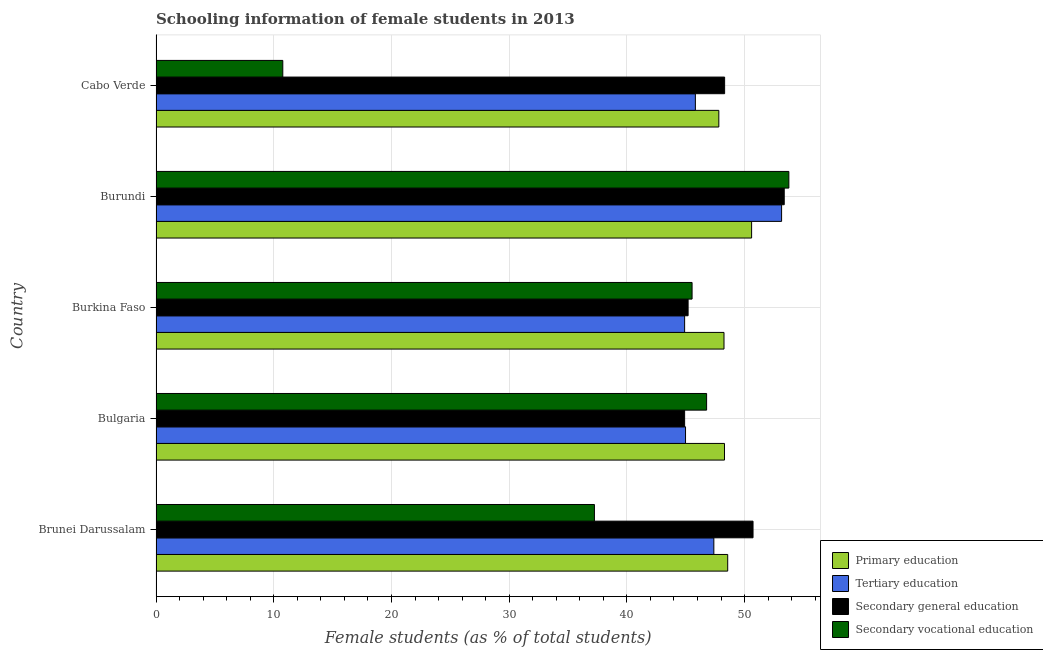How many groups of bars are there?
Your answer should be very brief. 5. Are the number of bars per tick equal to the number of legend labels?
Your answer should be very brief. Yes. Are the number of bars on each tick of the Y-axis equal?
Provide a short and direct response. Yes. How many bars are there on the 5th tick from the top?
Keep it short and to the point. 4. What is the label of the 3rd group of bars from the top?
Your answer should be very brief. Burkina Faso. What is the percentage of female students in tertiary education in Cabo Verde?
Give a very brief answer. 45.82. Across all countries, what is the maximum percentage of female students in tertiary education?
Your response must be concise. 53.14. Across all countries, what is the minimum percentage of female students in primary education?
Offer a very short reply. 47.81. In which country was the percentage of female students in secondary education maximum?
Provide a short and direct response. Burundi. What is the total percentage of female students in secondary education in the graph?
Offer a very short reply. 242.49. What is the difference between the percentage of female students in secondary education in Burundi and that in Cabo Verde?
Give a very brief answer. 5.07. What is the difference between the percentage of female students in secondary vocational education in Bulgaria and the percentage of female students in primary education in Cabo Verde?
Provide a short and direct response. -1.04. What is the average percentage of female students in secondary vocational education per country?
Offer a terse response. 38.82. What is the difference between the percentage of female students in tertiary education and percentage of female students in secondary education in Bulgaria?
Offer a very short reply. 0.08. In how many countries, is the percentage of female students in tertiary education greater than 48 %?
Offer a terse response. 1. What is the ratio of the percentage of female students in tertiary education in Bulgaria to that in Burundi?
Your answer should be compact. 0.85. Is the percentage of female students in secondary vocational education in Bulgaria less than that in Burkina Faso?
Ensure brevity in your answer.  No. What is the difference between the highest and the second highest percentage of female students in secondary vocational education?
Offer a terse response. 6.99. What is the difference between the highest and the lowest percentage of female students in tertiary education?
Provide a succinct answer. 8.24. Is the sum of the percentage of female students in secondary education in Brunei Darussalam and Bulgaria greater than the maximum percentage of female students in secondary vocational education across all countries?
Make the answer very short. Yes. Is it the case that in every country, the sum of the percentage of female students in tertiary education and percentage of female students in secondary education is greater than the sum of percentage of female students in primary education and percentage of female students in secondary vocational education?
Your answer should be very brief. No. What does the 4th bar from the top in Burkina Faso represents?
Provide a succinct answer. Primary education. What does the 1st bar from the bottom in Burundi represents?
Provide a short and direct response. Primary education. Are all the bars in the graph horizontal?
Offer a very short reply. Yes. How many countries are there in the graph?
Provide a short and direct response. 5. Are the values on the major ticks of X-axis written in scientific E-notation?
Provide a succinct answer. No. Does the graph contain any zero values?
Your response must be concise. No. Where does the legend appear in the graph?
Your response must be concise. Bottom right. How many legend labels are there?
Keep it short and to the point. 4. How are the legend labels stacked?
Offer a terse response. Vertical. What is the title of the graph?
Provide a succinct answer. Schooling information of female students in 2013. Does "Argument" appear as one of the legend labels in the graph?
Offer a very short reply. No. What is the label or title of the X-axis?
Offer a terse response. Female students (as % of total students). What is the label or title of the Y-axis?
Keep it short and to the point. Country. What is the Female students (as % of total students) of Primary education in Brunei Darussalam?
Make the answer very short. 48.56. What is the Female students (as % of total students) of Tertiary education in Brunei Darussalam?
Provide a succinct answer. 47.39. What is the Female students (as % of total students) of Secondary general education in Brunei Darussalam?
Give a very brief answer. 50.72. What is the Female students (as % of total students) in Secondary vocational education in Brunei Darussalam?
Your answer should be very brief. 37.24. What is the Female students (as % of total students) in Primary education in Bulgaria?
Provide a succinct answer. 48.29. What is the Female students (as % of total students) of Tertiary education in Bulgaria?
Provide a succinct answer. 44.98. What is the Female students (as % of total students) in Secondary general education in Bulgaria?
Provide a succinct answer. 44.91. What is the Female students (as % of total students) in Secondary vocational education in Bulgaria?
Your answer should be very brief. 46.77. What is the Female students (as % of total students) of Primary education in Burkina Faso?
Offer a terse response. 48.25. What is the Female students (as % of total students) of Tertiary education in Burkina Faso?
Your answer should be very brief. 44.91. What is the Female students (as % of total students) of Secondary general education in Burkina Faso?
Keep it short and to the point. 45.2. What is the Female students (as % of total students) of Secondary vocational education in Burkina Faso?
Offer a terse response. 45.54. What is the Female students (as % of total students) of Primary education in Burundi?
Offer a very short reply. 50.6. What is the Female students (as % of total students) of Tertiary education in Burundi?
Your answer should be very brief. 53.14. What is the Female students (as % of total students) in Secondary general education in Burundi?
Provide a succinct answer. 53.37. What is the Female students (as % of total students) of Secondary vocational education in Burundi?
Offer a very short reply. 53.76. What is the Female students (as % of total students) in Primary education in Cabo Verde?
Provide a succinct answer. 47.81. What is the Female students (as % of total students) in Tertiary education in Cabo Verde?
Your answer should be very brief. 45.82. What is the Female students (as % of total students) in Secondary general education in Cabo Verde?
Your response must be concise. 48.3. What is the Female students (as % of total students) in Secondary vocational education in Cabo Verde?
Give a very brief answer. 10.77. Across all countries, what is the maximum Female students (as % of total students) in Primary education?
Offer a terse response. 50.6. Across all countries, what is the maximum Female students (as % of total students) of Tertiary education?
Your answer should be compact. 53.14. Across all countries, what is the maximum Female students (as % of total students) in Secondary general education?
Keep it short and to the point. 53.37. Across all countries, what is the maximum Female students (as % of total students) in Secondary vocational education?
Your answer should be very brief. 53.76. Across all countries, what is the minimum Female students (as % of total students) in Primary education?
Make the answer very short. 47.81. Across all countries, what is the minimum Female students (as % of total students) in Tertiary education?
Ensure brevity in your answer.  44.91. Across all countries, what is the minimum Female students (as % of total students) in Secondary general education?
Provide a succinct answer. 44.91. Across all countries, what is the minimum Female students (as % of total students) in Secondary vocational education?
Give a very brief answer. 10.77. What is the total Female students (as % of total students) of Primary education in the graph?
Provide a short and direct response. 243.52. What is the total Female students (as % of total students) in Tertiary education in the graph?
Give a very brief answer. 236.24. What is the total Female students (as % of total students) of Secondary general education in the graph?
Give a very brief answer. 242.49. What is the total Female students (as % of total students) in Secondary vocational education in the graph?
Provide a short and direct response. 194.08. What is the difference between the Female students (as % of total students) of Primary education in Brunei Darussalam and that in Bulgaria?
Give a very brief answer. 0.27. What is the difference between the Female students (as % of total students) of Tertiary education in Brunei Darussalam and that in Bulgaria?
Offer a terse response. 2.4. What is the difference between the Female students (as % of total students) of Secondary general education in Brunei Darussalam and that in Bulgaria?
Your answer should be very brief. 5.81. What is the difference between the Female students (as % of total students) in Secondary vocational education in Brunei Darussalam and that in Bulgaria?
Offer a terse response. -9.53. What is the difference between the Female students (as % of total students) of Primary education in Brunei Darussalam and that in Burkina Faso?
Keep it short and to the point. 0.31. What is the difference between the Female students (as % of total students) of Tertiary education in Brunei Darussalam and that in Burkina Faso?
Your answer should be compact. 2.48. What is the difference between the Female students (as % of total students) of Secondary general education in Brunei Darussalam and that in Burkina Faso?
Give a very brief answer. 5.52. What is the difference between the Female students (as % of total students) of Secondary vocational education in Brunei Darussalam and that in Burkina Faso?
Provide a succinct answer. -8.3. What is the difference between the Female students (as % of total students) of Primary education in Brunei Darussalam and that in Burundi?
Give a very brief answer. -2.03. What is the difference between the Female students (as % of total students) of Tertiary education in Brunei Darussalam and that in Burundi?
Your response must be concise. -5.76. What is the difference between the Female students (as % of total students) in Secondary general education in Brunei Darussalam and that in Burundi?
Provide a succinct answer. -2.65. What is the difference between the Female students (as % of total students) of Secondary vocational education in Brunei Darussalam and that in Burundi?
Your answer should be very brief. -16.52. What is the difference between the Female students (as % of total students) of Primary education in Brunei Darussalam and that in Cabo Verde?
Your answer should be compact. 0.75. What is the difference between the Female students (as % of total students) in Tertiary education in Brunei Darussalam and that in Cabo Verde?
Your response must be concise. 1.57. What is the difference between the Female students (as % of total students) in Secondary general education in Brunei Darussalam and that in Cabo Verde?
Keep it short and to the point. 2.41. What is the difference between the Female students (as % of total students) in Secondary vocational education in Brunei Darussalam and that in Cabo Verde?
Your answer should be very brief. 26.47. What is the difference between the Female students (as % of total students) in Primary education in Bulgaria and that in Burkina Faso?
Offer a terse response. 0.04. What is the difference between the Female students (as % of total students) of Tertiary education in Bulgaria and that in Burkina Faso?
Ensure brevity in your answer.  0.08. What is the difference between the Female students (as % of total students) of Secondary general education in Bulgaria and that in Burkina Faso?
Offer a very short reply. -0.3. What is the difference between the Female students (as % of total students) in Secondary vocational education in Bulgaria and that in Burkina Faso?
Give a very brief answer. 1.24. What is the difference between the Female students (as % of total students) in Primary education in Bulgaria and that in Burundi?
Offer a very short reply. -2.3. What is the difference between the Female students (as % of total students) of Tertiary education in Bulgaria and that in Burundi?
Your response must be concise. -8.16. What is the difference between the Female students (as % of total students) in Secondary general education in Bulgaria and that in Burundi?
Your answer should be very brief. -8.46. What is the difference between the Female students (as % of total students) of Secondary vocational education in Bulgaria and that in Burundi?
Your answer should be compact. -6.99. What is the difference between the Female students (as % of total students) in Primary education in Bulgaria and that in Cabo Verde?
Offer a very short reply. 0.48. What is the difference between the Female students (as % of total students) of Tertiary education in Bulgaria and that in Cabo Verde?
Give a very brief answer. -0.84. What is the difference between the Female students (as % of total students) of Secondary general education in Bulgaria and that in Cabo Verde?
Your response must be concise. -3.4. What is the difference between the Female students (as % of total students) in Secondary vocational education in Bulgaria and that in Cabo Verde?
Your answer should be compact. 36. What is the difference between the Female students (as % of total students) in Primary education in Burkina Faso and that in Burundi?
Your response must be concise. -2.35. What is the difference between the Female students (as % of total students) in Tertiary education in Burkina Faso and that in Burundi?
Your answer should be compact. -8.24. What is the difference between the Female students (as % of total students) of Secondary general education in Burkina Faso and that in Burundi?
Offer a very short reply. -8.17. What is the difference between the Female students (as % of total students) in Secondary vocational education in Burkina Faso and that in Burundi?
Keep it short and to the point. -8.22. What is the difference between the Female students (as % of total students) of Primary education in Burkina Faso and that in Cabo Verde?
Your answer should be very brief. 0.44. What is the difference between the Female students (as % of total students) of Tertiary education in Burkina Faso and that in Cabo Verde?
Offer a very short reply. -0.91. What is the difference between the Female students (as % of total students) in Secondary general education in Burkina Faso and that in Cabo Verde?
Keep it short and to the point. -3.1. What is the difference between the Female students (as % of total students) of Secondary vocational education in Burkina Faso and that in Cabo Verde?
Ensure brevity in your answer.  34.77. What is the difference between the Female students (as % of total students) in Primary education in Burundi and that in Cabo Verde?
Make the answer very short. 2.78. What is the difference between the Female students (as % of total students) in Tertiary education in Burundi and that in Cabo Verde?
Provide a succinct answer. 7.32. What is the difference between the Female students (as % of total students) of Secondary general education in Burundi and that in Cabo Verde?
Keep it short and to the point. 5.06. What is the difference between the Female students (as % of total students) in Secondary vocational education in Burundi and that in Cabo Verde?
Ensure brevity in your answer.  42.99. What is the difference between the Female students (as % of total students) of Primary education in Brunei Darussalam and the Female students (as % of total students) of Tertiary education in Bulgaria?
Ensure brevity in your answer.  3.58. What is the difference between the Female students (as % of total students) in Primary education in Brunei Darussalam and the Female students (as % of total students) in Secondary general education in Bulgaria?
Offer a very short reply. 3.66. What is the difference between the Female students (as % of total students) in Primary education in Brunei Darussalam and the Female students (as % of total students) in Secondary vocational education in Bulgaria?
Make the answer very short. 1.79. What is the difference between the Female students (as % of total students) in Tertiary education in Brunei Darussalam and the Female students (as % of total students) in Secondary general education in Bulgaria?
Offer a terse response. 2.48. What is the difference between the Female students (as % of total students) in Tertiary education in Brunei Darussalam and the Female students (as % of total students) in Secondary vocational education in Bulgaria?
Make the answer very short. 0.61. What is the difference between the Female students (as % of total students) in Secondary general education in Brunei Darussalam and the Female students (as % of total students) in Secondary vocational education in Bulgaria?
Offer a very short reply. 3.94. What is the difference between the Female students (as % of total students) of Primary education in Brunei Darussalam and the Female students (as % of total students) of Tertiary education in Burkina Faso?
Provide a short and direct response. 3.66. What is the difference between the Female students (as % of total students) in Primary education in Brunei Darussalam and the Female students (as % of total students) in Secondary general education in Burkina Faso?
Make the answer very short. 3.36. What is the difference between the Female students (as % of total students) of Primary education in Brunei Darussalam and the Female students (as % of total students) of Secondary vocational education in Burkina Faso?
Offer a very short reply. 3.03. What is the difference between the Female students (as % of total students) of Tertiary education in Brunei Darussalam and the Female students (as % of total students) of Secondary general education in Burkina Faso?
Give a very brief answer. 2.19. What is the difference between the Female students (as % of total students) of Tertiary education in Brunei Darussalam and the Female students (as % of total students) of Secondary vocational education in Burkina Faso?
Provide a short and direct response. 1.85. What is the difference between the Female students (as % of total students) in Secondary general education in Brunei Darussalam and the Female students (as % of total students) in Secondary vocational education in Burkina Faso?
Offer a terse response. 5.18. What is the difference between the Female students (as % of total students) in Primary education in Brunei Darussalam and the Female students (as % of total students) in Tertiary education in Burundi?
Make the answer very short. -4.58. What is the difference between the Female students (as % of total students) of Primary education in Brunei Darussalam and the Female students (as % of total students) of Secondary general education in Burundi?
Give a very brief answer. -4.8. What is the difference between the Female students (as % of total students) of Primary education in Brunei Darussalam and the Female students (as % of total students) of Secondary vocational education in Burundi?
Give a very brief answer. -5.2. What is the difference between the Female students (as % of total students) of Tertiary education in Brunei Darussalam and the Female students (as % of total students) of Secondary general education in Burundi?
Make the answer very short. -5.98. What is the difference between the Female students (as % of total students) in Tertiary education in Brunei Darussalam and the Female students (as % of total students) in Secondary vocational education in Burundi?
Offer a terse response. -6.37. What is the difference between the Female students (as % of total students) in Secondary general education in Brunei Darussalam and the Female students (as % of total students) in Secondary vocational education in Burundi?
Provide a succinct answer. -3.04. What is the difference between the Female students (as % of total students) of Primary education in Brunei Darussalam and the Female students (as % of total students) of Tertiary education in Cabo Verde?
Provide a succinct answer. 2.75. What is the difference between the Female students (as % of total students) in Primary education in Brunei Darussalam and the Female students (as % of total students) in Secondary general education in Cabo Verde?
Make the answer very short. 0.26. What is the difference between the Female students (as % of total students) in Primary education in Brunei Darussalam and the Female students (as % of total students) in Secondary vocational education in Cabo Verde?
Your answer should be very brief. 37.8. What is the difference between the Female students (as % of total students) in Tertiary education in Brunei Darussalam and the Female students (as % of total students) in Secondary general education in Cabo Verde?
Your answer should be compact. -0.92. What is the difference between the Female students (as % of total students) of Tertiary education in Brunei Darussalam and the Female students (as % of total students) of Secondary vocational education in Cabo Verde?
Keep it short and to the point. 36.62. What is the difference between the Female students (as % of total students) of Secondary general education in Brunei Darussalam and the Female students (as % of total students) of Secondary vocational education in Cabo Verde?
Your answer should be compact. 39.95. What is the difference between the Female students (as % of total students) in Primary education in Bulgaria and the Female students (as % of total students) in Tertiary education in Burkina Faso?
Keep it short and to the point. 3.39. What is the difference between the Female students (as % of total students) in Primary education in Bulgaria and the Female students (as % of total students) in Secondary general education in Burkina Faso?
Your answer should be compact. 3.09. What is the difference between the Female students (as % of total students) of Primary education in Bulgaria and the Female students (as % of total students) of Secondary vocational education in Burkina Faso?
Your answer should be very brief. 2.75. What is the difference between the Female students (as % of total students) of Tertiary education in Bulgaria and the Female students (as % of total students) of Secondary general education in Burkina Faso?
Offer a terse response. -0.22. What is the difference between the Female students (as % of total students) of Tertiary education in Bulgaria and the Female students (as % of total students) of Secondary vocational education in Burkina Faso?
Keep it short and to the point. -0.56. What is the difference between the Female students (as % of total students) of Secondary general education in Bulgaria and the Female students (as % of total students) of Secondary vocational education in Burkina Faso?
Keep it short and to the point. -0.63. What is the difference between the Female students (as % of total students) of Primary education in Bulgaria and the Female students (as % of total students) of Tertiary education in Burundi?
Provide a short and direct response. -4.85. What is the difference between the Female students (as % of total students) in Primary education in Bulgaria and the Female students (as % of total students) in Secondary general education in Burundi?
Provide a succinct answer. -5.08. What is the difference between the Female students (as % of total students) in Primary education in Bulgaria and the Female students (as % of total students) in Secondary vocational education in Burundi?
Ensure brevity in your answer.  -5.47. What is the difference between the Female students (as % of total students) of Tertiary education in Bulgaria and the Female students (as % of total students) of Secondary general education in Burundi?
Your answer should be very brief. -8.39. What is the difference between the Female students (as % of total students) of Tertiary education in Bulgaria and the Female students (as % of total students) of Secondary vocational education in Burundi?
Give a very brief answer. -8.78. What is the difference between the Female students (as % of total students) in Secondary general education in Bulgaria and the Female students (as % of total students) in Secondary vocational education in Burundi?
Make the answer very short. -8.86. What is the difference between the Female students (as % of total students) in Primary education in Bulgaria and the Female students (as % of total students) in Tertiary education in Cabo Verde?
Provide a short and direct response. 2.47. What is the difference between the Female students (as % of total students) in Primary education in Bulgaria and the Female students (as % of total students) in Secondary general education in Cabo Verde?
Offer a terse response. -0.01. What is the difference between the Female students (as % of total students) in Primary education in Bulgaria and the Female students (as % of total students) in Secondary vocational education in Cabo Verde?
Your answer should be compact. 37.52. What is the difference between the Female students (as % of total students) in Tertiary education in Bulgaria and the Female students (as % of total students) in Secondary general education in Cabo Verde?
Ensure brevity in your answer.  -3.32. What is the difference between the Female students (as % of total students) of Tertiary education in Bulgaria and the Female students (as % of total students) of Secondary vocational education in Cabo Verde?
Offer a very short reply. 34.21. What is the difference between the Female students (as % of total students) of Secondary general education in Bulgaria and the Female students (as % of total students) of Secondary vocational education in Cabo Verde?
Offer a very short reply. 34.14. What is the difference between the Female students (as % of total students) of Primary education in Burkina Faso and the Female students (as % of total students) of Tertiary education in Burundi?
Offer a very short reply. -4.89. What is the difference between the Female students (as % of total students) in Primary education in Burkina Faso and the Female students (as % of total students) in Secondary general education in Burundi?
Provide a succinct answer. -5.12. What is the difference between the Female students (as % of total students) of Primary education in Burkina Faso and the Female students (as % of total students) of Secondary vocational education in Burundi?
Make the answer very short. -5.51. What is the difference between the Female students (as % of total students) of Tertiary education in Burkina Faso and the Female students (as % of total students) of Secondary general education in Burundi?
Your answer should be very brief. -8.46. What is the difference between the Female students (as % of total students) of Tertiary education in Burkina Faso and the Female students (as % of total students) of Secondary vocational education in Burundi?
Provide a succinct answer. -8.86. What is the difference between the Female students (as % of total students) of Secondary general education in Burkina Faso and the Female students (as % of total students) of Secondary vocational education in Burundi?
Offer a terse response. -8.56. What is the difference between the Female students (as % of total students) in Primary education in Burkina Faso and the Female students (as % of total students) in Tertiary education in Cabo Verde?
Offer a very short reply. 2.43. What is the difference between the Female students (as % of total students) in Primary education in Burkina Faso and the Female students (as % of total students) in Secondary general education in Cabo Verde?
Offer a very short reply. -0.05. What is the difference between the Female students (as % of total students) of Primary education in Burkina Faso and the Female students (as % of total students) of Secondary vocational education in Cabo Verde?
Give a very brief answer. 37.48. What is the difference between the Female students (as % of total students) in Tertiary education in Burkina Faso and the Female students (as % of total students) in Secondary general education in Cabo Verde?
Offer a terse response. -3.4. What is the difference between the Female students (as % of total students) in Tertiary education in Burkina Faso and the Female students (as % of total students) in Secondary vocational education in Cabo Verde?
Offer a terse response. 34.14. What is the difference between the Female students (as % of total students) of Secondary general education in Burkina Faso and the Female students (as % of total students) of Secondary vocational education in Cabo Verde?
Give a very brief answer. 34.43. What is the difference between the Female students (as % of total students) of Primary education in Burundi and the Female students (as % of total students) of Tertiary education in Cabo Verde?
Ensure brevity in your answer.  4.78. What is the difference between the Female students (as % of total students) in Primary education in Burundi and the Female students (as % of total students) in Secondary general education in Cabo Verde?
Your answer should be very brief. 2.29. What is the difference between the Female students (as % of total students) of Primary education in Burundi and the Female students (as % of total students) of Secondary vocational education in Cabo Verde?
Give a very brief answer. 39.83. What is the difference between the Female students (as % of total students) in Tertiary education in Burundi and the Female students (as % of total students) in Secondary general education in Cabo Verde?
Offer a very short reply. 4.84. What is the difference between the Female students (as % of total students) in Tertiary education in Burundi and the Female students (as % of total students) in Secondary vocational education in Cabo Verde?
Make the answer very short. 42.37. What is the difference between the Female students (as % of total students) in Secondary general education in Burundi and the Female students (as % of total students) in Secondary vocational education in Cabo Verde?
Your answer should be very brief. 42.6. What is the average Female students (as % of total students) in Primary education per country?
Your answer should be compact. 48.7. What is the average Female students (as % of total students) in Tertiary education per country?
Offer a very short reply. 47.25. What is the average Female students (as % of total students) in Secondary general education per country?
Your answer should be very brief. 48.5. What is the average Female students (as % of total students) of Secondary vocational education per country?
Make the answer very short. 38.82. What is the difference between the Female students (as % of total students) of Primary education and Female students (as % of total students) of Tertiary education in Brunei Darussalam?
Your answer should be compact. 1.18. What is the difference between the Female students (as % of total students) in Primary education and Female students (as % of total students) in Secondary general education in Brunei Darussalam?
Offer a very short reply. -2.15. What is the difference between the Female students (as % of total students) of Primary education and Female students (as % of total students) of Secondary vocational education in Brunei Darussalam?
Provide a short and direct response. 11.32. What is the difference between the Female students (as % of total students) of Tertiary education and Female students (as % of total students) of Secondary general education in Brunei Darussalam?
Ensure brevity in your answer.  -3.33. What is the difference between the Female students (as % of total students) of Tertiary education and Female students (as % of total students) of Secondary vocational education in Brunei Darussalam?
Keep it short and to the point. 10.15. What is the difference between the Female students (as % of total students) in Secondary general education and Female students (as % of total students) in Secondary vocational education in Brunei Darussalam?
Your answer should be very brief. 13.47. What is the difference between the Female students (as % of total students) of Primary education and Female students (as % of total students) of Tertiary education in Bulgaria?
Ensure brevity in your answer.  3.31. What is the difference between the Female students (as % of total students) of Primary education and Female students (as % of total students) of Secondary general education in Bulgaria?
Your answer should be compact. 3.39. What is the difference between the Female students (as % of total students) of Primary education and Female students (as % of total students) of Secondary vocational education in Bulgaria?
Make the answer very short. 1.52. What is the difference between the Female students (as % of total students) of Tertiary education and Female students (as % of total students) of Secondary general education in Bulgaria?
Make the answer very short. 0.08. What is the difference between the Female students (as % of total students) of Tertiary education and Female students (as % of total students) of Secondary vocational education in Bulgaria?
Offer a terse response. -1.79. What is the difference between the Female students (as % of total students) of Secondary general education and Female students (as % of total students) of Secondary vocational education in Bulgaria?
Your answer should be very brief. -1.87. What is the difference between the Female students (as % of total students) of Primary education and Female students (as % of total students) of Tertiary education in Burkina Faso?
Make the answer very short. 3.35. What is the difference between the Female students (as % of total students) in Primary education and Female students (as % of total students) in Secondary general education in Burkina Faso?
Offer a terse response. 3.05. What is the difference between the Female students (as % of total students) of Primary education and Female students (as % of total students) of Secondary vocational education in Burkina Faso?
Your answer should be very brief. 2.71. What is the difference between the Female students (as % of total students) in Tertiary education and Female students (as % of total students) in Secondary general education in Burkina Faso?
Ensure brevity in your answer.  -0.3. What is the difference between the Female students (as % of total students) in Tertiary education and Female students (as % of total students) in Secondary vocational education in Burkina Faso?
Your answer should be compact. -0.63. What is the difference between the Female students (as % of total students) in Secondary general education and Female students (as % of total students) in Secondary vocational education in Burkina Faso?
Provide a short and direct response. -0.34. What is the difference between the Female students (as % of total students) in Primary education and Female students (as % of total students) in Tertiary education in Burundi?
Provide a short and direct response. -2.55. What is the difference between the Female students (as % of total students) in Primary education and Female students (as % of total students) in Secondary general education in Burundi?
Your answer should be very brief. -2.77. What is the difference between the Female students (as % of total students) in Primary education and Female students (as % of total students) in Secondary vocational education in Burundi?
Offer a terse response. -3.16. What is the difference between the Female students (as % of total students) in Tertiary education and Female students (as % of total students) in Secondary general education in Burundi?
Your answer should be very brief. -0.22. What is the difference between the Female students (as % of total students) in Tertiary education and Female students (as % of total students) in Secondary vocational education in Burundi?
Offer a very short reply. -0.62. What is the difference between the Female students (as % of total students) of Secondary general education and Female students (as % of total students) of Secondary vocational education in Burundi?
Your response must be concise. -0.39. What is the difference between the Female students (as % of total students) of Primary education and Female students (as % of total students) of Tertiary education in Cabo Verde?
Your answer should be very brief. 1.99. What is the difference between the Female students (as % of total students) of Primary education and Female students (as % of total students) of Secondary general education in Cabo Verde?
Offer a terse response. -0.49. What is the difference between the Female students (as % of total students) of Primary education and Female students (as % of total students) of Secondary vocational education in Cabo Verde?
Your answer should be very brief. 37.04. What is the difference between the Female students (as % of total students) in Tertiary education and Female students (as % of total students) in Secondary general education in Cabo Verde?
Offer a very short reply. -2.48. What is the difference between the Female students (as % of total students) of Tertiary education and Female students (as % of total students) of Secondary vocational education in Cabo Verde?
Ensure brevity in your answer.  35.05. What is the difference between the Female students (as % of total students) in Secondary general education and Female students (as % of total students) in Secondary vocational education in Cabo Verde?
Keep it short and to the point. 37.53. What is the ratio of the Female students (as % of total students) of Primary education in Brunei Darussalam to that in Bulgaria?
Provide a succinct answer. 1.01. What is the ratio of the Female students (as % of total students) in Tertiary education in Brunei Darussalam to that in Bulgaria?
Offer a terse response. 1.05. What is the ratio of the Female students (as % of total students) of Secondary general education in Brunei Darussalam to that in Bulgaria?
Your answer should be compact. 1.13. What is the ratio of the Female students (as % of total students) in Secondary vocational education in Brunei Darussalam to that in Bulgaria?
Offer a very short reply. 0.8. What is the ratio of the Female students (as % of total students) of Tertiary education in Brunei Darussalam to that in Burkina Faso?
Your answer should be compact. 1.06. What is the ratio of the Female students (as % of total students) of Secondary general education in Brunei Darussalam to that in Burkina Faso?
Keep it short and to the point. 1.12. What is the ratio of the Female students (as % of total students) in Secondary vocational education in Brunei Darussalam to that in Burkina Faso?
Offer a terse response. 0.82. What is the ratio of the Female students (as % of total students) in Primary education in Brunei Darussalam to that in Burundi?
Your answer should be very brief. 0.96. What is the ratio of the Female students (as % of total students) in Tertiary education in Brunei Darussalam to that in Burundi?
Your answer should be compact. 0.89. What is the ratio of the Female students (as % of total students) in Secondary general education in Brunei Darussalam to that in Burundi?
Offer a terse response. 0.95. What is the ratio of the Female students (as % of total students) in Secondary vocational education in Brunei Darussalam to that in Burundi?
Make the answer very short. 0.69. What is the ratio of the Female students (as % of total students) of Primary education in Brunei Darussalam to that in Cabo Verde?
Ensure brevity in your answer.  1.02. What is the ratio of the Female students (as % of total students) in Tertiary education in Brunei Darussalam to that in Cabo Verde?
Keep it short and to the point. 1.03. What is the ratio of the Female students (as % of total students) in Secondary general education in Brunei Darussalam to that in Cabo Verde?
Make the answer very short. 1.05. What is the ratio of the Female students (as % of total students) in Secondary vocational education in Brunei Darussalam to that in Cabo Verde?
Offer a very short reply. 3.46. What is the ratio of the Female students (as % of total students) in Primary education in Bulgaria to that in Burkina Faso?
Ensure brevity in your answer.  1. What is the ratio of the Female students (as % of total students) of Secondary vocational education in Bulgaria to that in Burkina Faso?
Keep it short and to the point. 1.03. What is the ratio of the Female students (as % of total students) in Primary education in Bulgaria to that in Burundi?
Give a very brief answer. 0.95. What is the ratio of the Female students (as % of total students) in Tertiary education in Bulgaria to that in Burundi?
Offer a very short reply. 0.85. What is the ratio of the Female students (as % of total students) of Secondary general education in Bulgaria to that in Burundi?
Keep it short and to the point. 0.84. What is the ratio of the Female students (as % of total students) in Secondary vocational education in Bulgaria to that in Burundi?
Your answer should be very brief. 0.87. What is the ratio of the Female students (as % of total students) of Tertiary education in Bulgaria to that in Cabo Verde?
Offer a very short reply. 0.98. What is the ratio of the Female students (as % of total students) in Secondary general education in Bulgaria to that in Cabo Verde?
Your answer should be very brief. 0.93. What is the ratio of the Female students (as % of total students) in Secondary vocational education in Bulgaria to that in Cabo Verde?
Make the answer very short. 4.34. What is the ratio of the Female students (as % of total students) of Primary education in Burkina Faso to that in Burundi?
Offer a terse response. 0.95. What is the ratio of the Female students (as % of total students) of Tertiary education in Burkina Faso to that in Burundi?
Give a very brief answer. 0.84. What is the ratio of the Female students (as % of total students) of Secondary general education in Burkina Faso to that in Burundi?
Keep it short and to the point. 0.85. What is the ratio of the Female students (as % of total students) of Secondary vocational education in Burkina Faso to that in Burundi?
Make the answer very short. 0.85. What is the ratio of the Female students (as % of total students) in Primary education in Burkina Faso to that in Cabo Verde?
Give a very brief answer. 1.01. What is the ratio of the Female students (as % of total students) in Tertiary education in Burkina Faso to that in Cabo Verde?
Offer a terse response. 0.98. What is the ratio of the Female students (as % of total students) of Secondary general education in Burkina Faso to that in Cabo Verde?
Your answer should be very brief. 0.94. What is the ratio of the Female students (as % of total students) in Secondary vocational education in Burkina Faso to that in Cabo Verde?
Offer a very short reply. 4.23. What is the ratio of the Female students (as % of total students) of Primary education in Burundi to that in Cabo Verde?
Ensure brevity in your answer.  1.06. What is the ratio of the Female students (as % of total students) of Tertiary education in Burundi to that in Cabo Verde?
Give a very brief answer. 1.16. What is the ratio of the Female students (as % of total students) in Secondary general education in Burundi to that in Cabo Verde?
Your answer should be very brief. 1.1. What is the ratio of the Female students (as % of total students) in Secondary vocational education in Burundi to that in Cabo Verde?
Offer a very short reply. 4.99. What is the difference between the highest and the second highest Female students (as % of total students) in Primary education?
Offer a terse response. 2.03. What is the difference between the highest and the second highest Female students (as % of total students) in Tertiary education?
Keep it short and to the point. 5.76. What is the difference between the highest and the second highest Female students (as % of total students) of Secondary general education?
Give a very brief answer. 2.65. What is the difference between the highest and the second highest Female students (as % of total students) in Secondary vocational education?
Your answer should be very brief. 6.99. What is the difference between the highest and the lowest Female students (as % of total students) in Primary education?
Offer a terse response. 2.78. What is the difference between the highest and the lowest Female students (as % of total students) of Tertiary education?
Give a very brief answer. 8.24. What is the difference between the highest and the lowest Female students (as % of total students) in Secondary general education?
Offer a very short reply. 8.46. What is the difference between the highest and the lowest Female students (as % of total students) in Secondary vocational education?
Give a very brief answer. 42.99. 